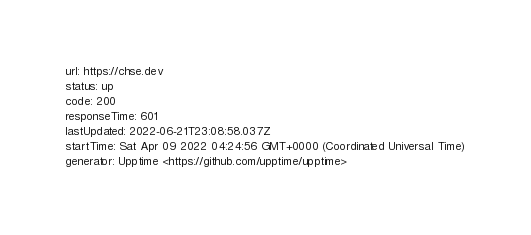Convert code to text. <code><loc_0><loc_0><loc_500><loc_500><_YAML_>url: https://chse.dev
status: up
code: 200
responseTime: 601
lastUpdated: 2022-06-21T23:08:58.037Z
startTime: Sat Apr 09 2022 04:24:56 GMT+0000 (Coordinated Universal Time)
generator: Upptime <https://github.com/upptime/upptime>
</code> 